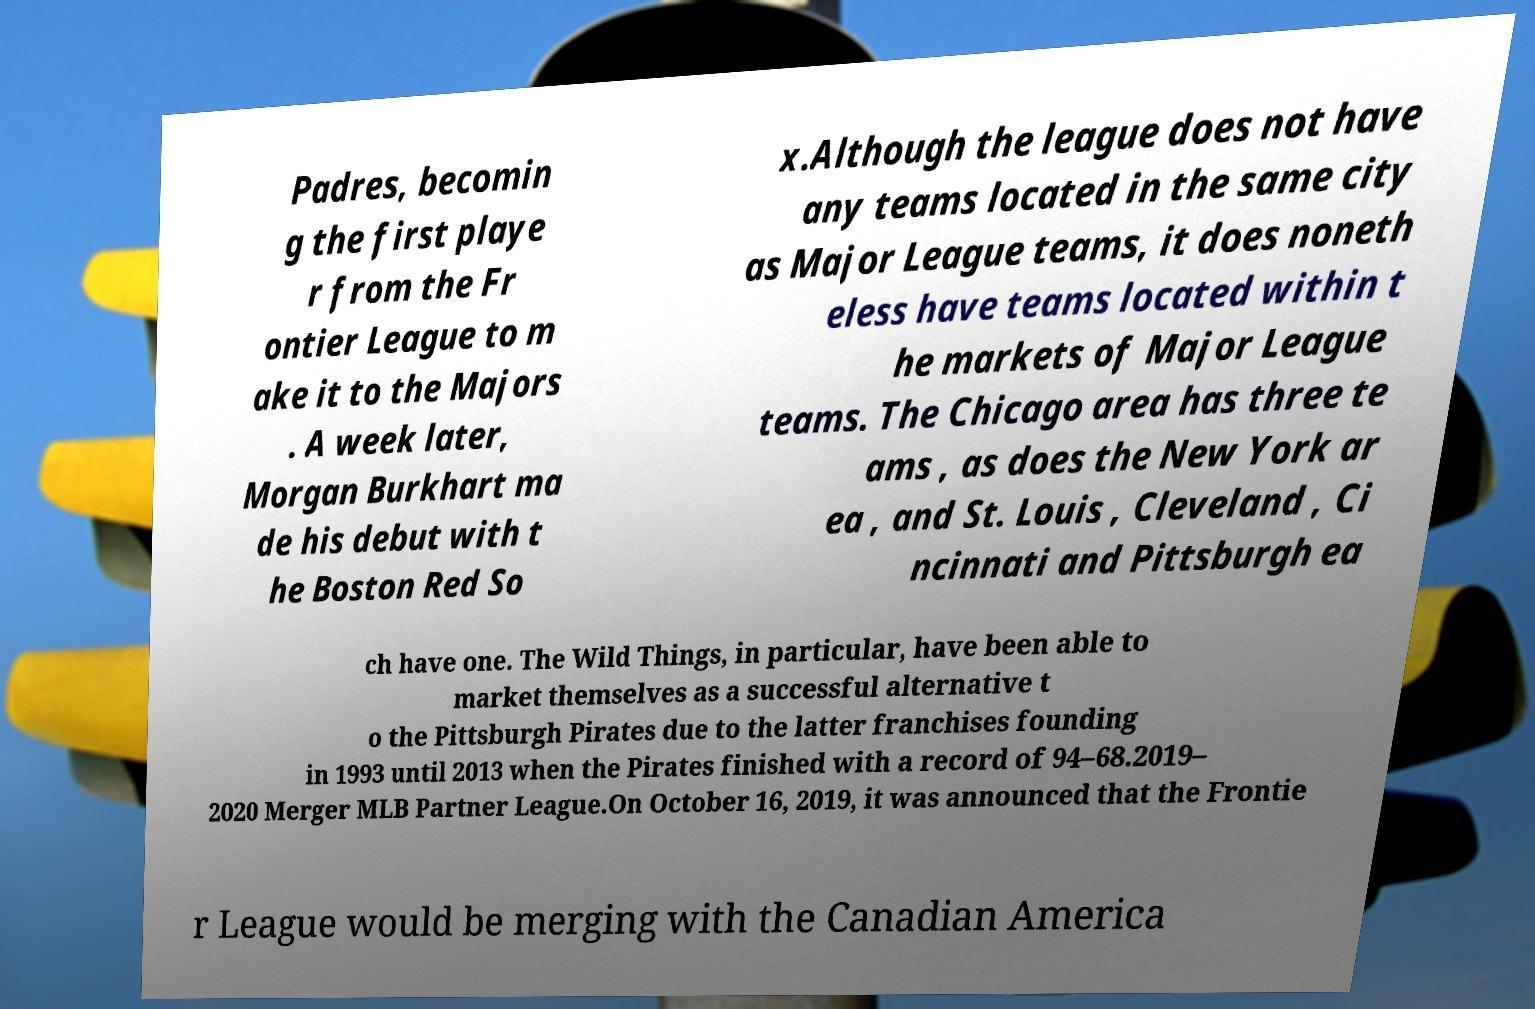Could you extract and type out the text from this image? Padres, becomin g the first playe r from the Fr ontier League to m ake it to the Majors . A week later, Morgan Burkhart ma de his debut with t he Boston Red So x.Although the league does not have any teams located in the same city as Major League teams, it does noneth eless have teams located within t he markets of Major League teams. The Chicago area has three te ams , as does the New York ar ea , and St. Louis , Cleveland , Ci ncinnati and Pittsburgh ea ch have one. The Wild Things, in particular, have been able to market themselves as a successful alternative t o the Pittsburgh Pirates due to the latter franchises founding in 1993 until 2013 when the Pirates finished with a record of 94–68.2019– 2020 Merger MLB Partner League.On October 16, 2019, it was announced that the Frontie r League would be merging with the Canadian America 